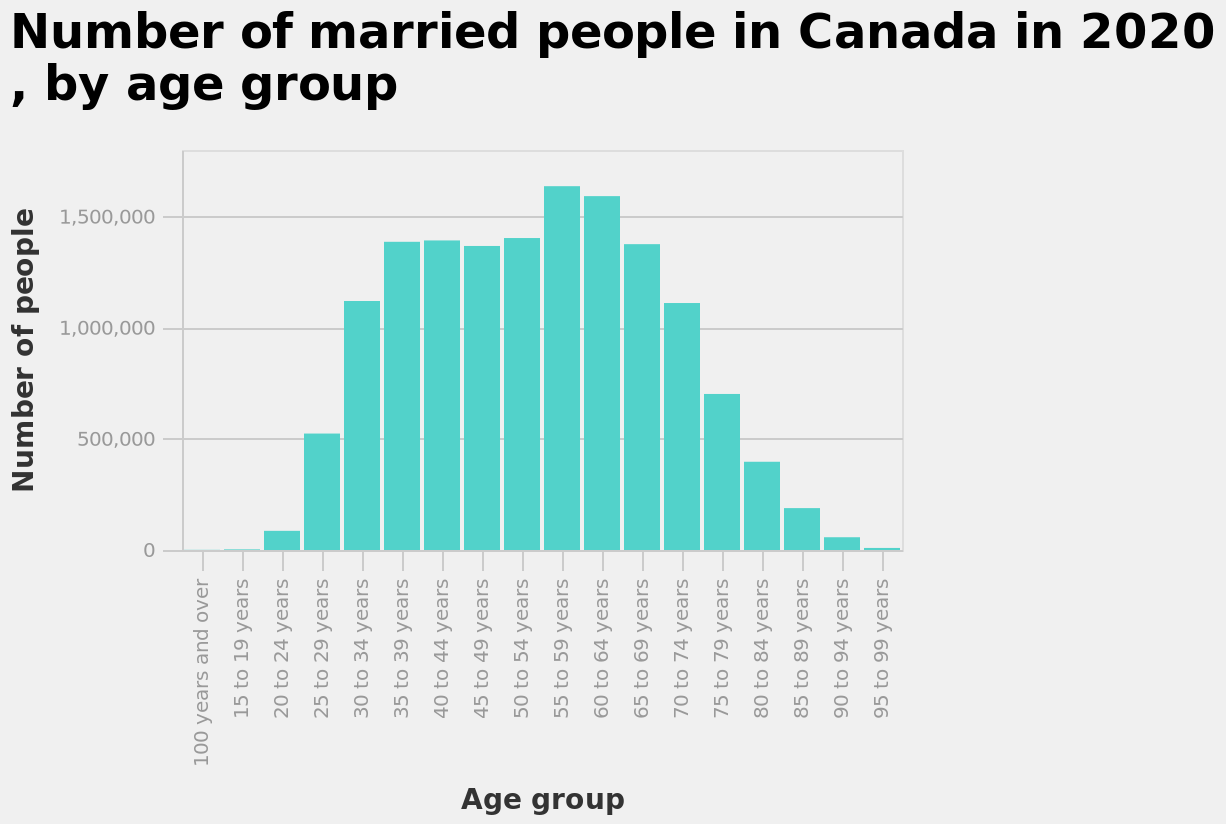<image>
What does the x-axis represent in the bar diagram?  The x-axis represents the age group. What can be concluded from the visualization regarding the age distribution of married people in Canada? It can be concluded from the visualization that most people who are married in Canada fall into the age range of 30-79 years old. What information does the bar diagram provide? The bar diagram provides information about the number of married people in Canada in 2020, with the data categorized by age group. Offer a thorough analysis of the image. The age group with the most number of people married in Canada in 2020 was 55-59 year olds. Either side of this age group, the numbers decrease. The age groups with the lowest number of people married were 100 years and over, 15-19 year olds, 20-24 year olds, 85 to 89 year olds, 90 to 94 year old and 95 to 99 year olds. From this visualisation it can be seen that most people who are married are between 30-79 years old. Can it be concluded from the visualization that most people who are married in Canada fall into the age range of 18-20 years old? No.It can be concluded from the visualization that most people who are married in Canada fall into the age range of 30-79 years old. 